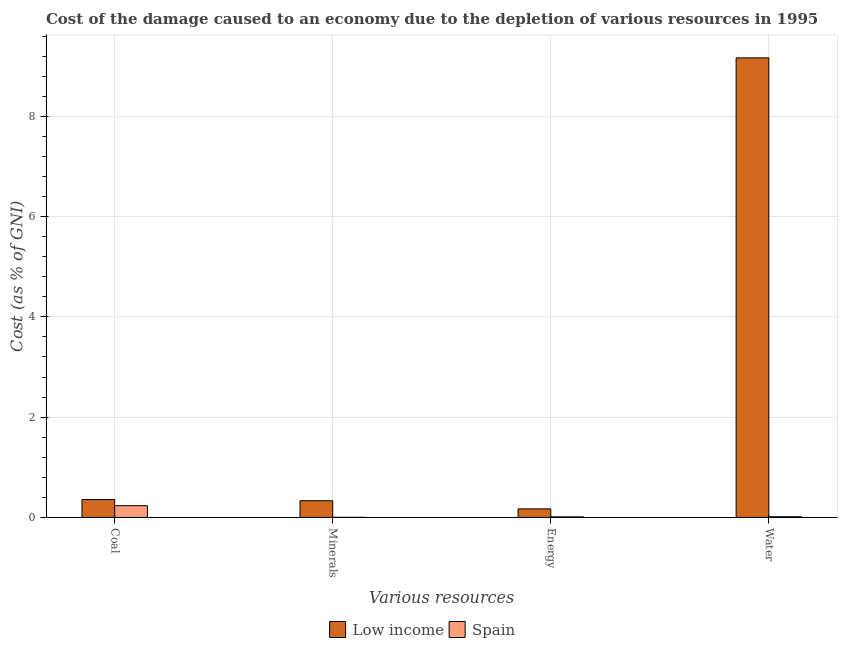How many different coloured bars are there?
Your response must be concise. 2. How many groups of bars are there?
Your answer should be very brief. 4. Are the number of bars per tick equal to the number of legend labels?
Your answer should be compact. Yes. Are the number of bars on each tick of the X-axis equal?
Provide a succinct answer. Yes. How many bars are there on the 1st tick from the left?
Your answer should be compact. 2. What is the label of the 2nd group of bars from the left?
Provide a short and direct response. Minerals. What is the cost of damage due to depletion of energy in Low income?
Provide a succinct answer. 0.17. Across all countries, what is the maximum cost of damage due to depletion of coal?
Provide a succinct answer. 0.36. Across all countries, what is the minimum cost of damage due to depletion of energy?
Your answer should be very brief. 0.01. In which country was the cost of damage due to depletion of energy maximum?
Provide a short and direct response. Low income. What is the total cost of damage due to depletion of energy in the graph?
Give a very brief answer. 0.18. What is the difference between the cost of damage due to depletion of coal in Spain and that in Low income?
Provide a short and direct response. -0.12. What is the difference between the cost of damage due to depletion of coal in Low income and the cost of damage due to depletion of energy in Spain?
Make the answer very short. 0.34. What is the average cost of damage due to depletion of minerals per country?
Ensure brevity in your answer.  0.17. What is the difference between the cost of damage due to depletion of energy and cost of damage due to depletion of minerals in Spain?
Your answer should be very brief. 0.01. What is the ratio of the cost of damage due to depletion of water in Spain to that in Low income?
Provide a succinct answer. 0. What is the difference between the highest and the second highest cost of damage due to depletion of energy?
Your answer should be very brief. 0.16. What is the difference between the highest and the lowest cost of damage due to depletion of water?
Make the answer very short. 9.15. What does the 1st bar from the left in Energy represents?
Your answer should be compact. Low income. How many bars are there?
Offer a very short reply. 8. Are all the bars in the graph horizontal?
Your response must be concise. No. How many countries are there in the graph?
Ensure brevity in your answer.  2. What is the title of the graph?
Offer a terse response. Cost of the damage caused to an economy due to the depletion of various resources in 1995 . Does "Brunei Darussalam" appear as one of the legend labels in the graph?
Provide a short and direct response. No. What is the label or title of the X-axis?
Offer a terse response. Various resources. What is the label or title of the Y-axis?
Give a very brief answer. Cost (as % of GNI). What is the Cost (as % of GNI) of Low income in Coal?
Your answer should be compact. 0.36. What is the Cost (as % of GNI) in Spain in Coal?
Provide a succinct answer. 0.23. What is the Cost (as % of GNI) in Low income in Minerals?
Offer a very short reply. 0.33. What is the Cost (as % of GNI) of Spain in Minerals?
Your answer should be very brief. 0. What is the Cost (as % of GNI) in Low income in Energy?
Make the answer very short. 0.17. What is the Cost (as % of GNI) in Spain in Energy?
Make the answer very short. 0.01. What is the Cost (as % of GNI) in Low income in Water?
Your response must be concise. 9.16. What is the Cost (as % of GNI) of Spain in Water?
Your response must be concise. 0.01. Across all Various resources, what is the maximum Cost (as % of GNI) of Low income?
Give a very brief answer. 9.16. Across all Various resources, what is the maximum Cost (as % of GNI) in Spain?
Make the answer very short. 0.23. Across all Various resources, what is the minimum Cost (as % of GNI) of Low income?
Offer a terse response. 0.17. Across all Various resources, what is the minimum Cost (as % of GNI) in Spain?
Provide a succinct answer. 0. What is the total Cost (as % of GNI) of Low income in the graph?
Offer a terse response. 10.02. What is the total Cost (as % of GNI) of Spain in the graph?
Offer a very short reply. 0.26. What is the difference between the Cost (as % of GNI) of Low income in Coal and that in Minerals?
Give a very brief answer. 0.02. What is the difference between the Cost (as % of GNI) in Spain in Coal and that in Minerals?
Provide a short and direct response. 0.23. What is the difference between the Cost (as % of GNI) of Low income in Coal and that in Energy?
Your response must be concise. 0.19. What is the difference between the Cost (as % of GNI) of Spain in Coal and that in Energy?
Offer a terse response. 0.22. What is the difference between the Cost (as % of GNI) of Low income in Coal and that in Water?
Your answer should be compact. -8.81. What is the difference between the Cost (as % of GNI) in Spain in Coal and that in Water?
Ensure brevity in your answer.  0.22. What is the difference between the Cost (as % of GNI) of Low income in Minerals and that in Energy?
Offer a terse response. 0.16. What is the difference between the Cost (as % of GNI) of Spain in Minerals and that in Energy?
Provide a short and direct response. -0.01. What is the difference between the Cost (as % of GNI) of Low income in Minerals and that in Water?
Make the answer very short. -8.83. What is the difference between the Cost (as % of GNI) of Spain in Minerals and that in Water?
Make the answer very short. -0.01. What is the difference between the Cost (as % of GNI) of Low income in Energy and that in Water?
Your response must be concise. -8.99. What is the difference between the Cost (as % of GNI) in Spain in Energy and that in Water?
Make the answer very short. -0. What is the difference between the Cost (as % of GNI) in Low income in Coal and the Cost (as % of GNI) in Spain in Minerals?
Ensure brevity in your answer.  0.35. What is the difference between the Cost (as % of GNI) of Low income in Coal and the Cost (as % of GNI) of Spain in Energy?
Your answer should be compact. 0.34. What is the difference between the Cost (as % of GNI) in Low income in Coal and the Cost (as % of GNI) in Spain in Water?
Keep it short and to the point. 0.34. What is the difference between the Cost (as % of GNI) in Low income in Minerals and the Cost (as % of GNI) in Spain in Energy?
Your response must be concise. 0.32. What is the difference between the Cost (as % of GNI) in Low income in Minerals and the Cost (as % of GNI) in Spain in Water?
Make the answer very short. 0.32. What is the difference between the Cost (as % of GNI) of Low income in Energy and the Cost (as % of GNI) of Spain in Water?
Provide a succinct answer. 0.16. What is the average Cost (as % of GNI) in Low income per Various resources?
Offer a terse response. 2.51. What is the average Cost (as % of GNI) of Spain per Various resources?
Offer a very short reply. 0.07. What is the difference between the Cost (as % of GNI) of Low income and Cost (as % of GNI) of Spain in Coal?
Keep it short and to the point. 0.12. What is the difference between the Cost (as % of GNI) of Low income and Cost (as % of GNI) of Spain in Minerals?
Provide a succinct answer. 0.33. What is the difference between the Cost (as % of GNI) in Low income and Cost (as % of GNI) in Spain in Energy?
Ensure brevity in your answer.  0.16. What is the difference between the Cost (as % of GNI) of Low income and Cost (as % of GNI) of Spain in Water?
Provide a succinct answer. 9.15. What is the ratio of the Cost (as % of GNI) in Low income in Coal to that in Minerals?
Keep it short and to the point. 1.07. What is the ratio of the Cost (as % of GNI) in Spain in Coal to that in Minerals?
Make the answer very short. 127.5. What is the ratio of the Cost (as % of GNI) in Low income in Coal to that in Energy?
Give a very brief answer. 2.09. What is the ratio of the Cost (as % of GNI) of Spain in Coal to that in Energy?
Offer a terse response. 20.49. What is the ratio of the Cost (as % of GNI) of Low income in Coal to that in Water?
Ensure brevity in your answer.  0.04. What is the ratio of the Cost (as % of GNI) in Spain in Coal to that in Water?
Provide a succinct answer. 17.66. What is the ratio of the Cost (as % of GNI) of Low income in Minerals to that in Energy?
Your response must be concise. 1.95. What is the ratio of the Cost (as % of GNI) of Spain in Minerals to that in Energy?
Offer a very short reply. 0.16. What is the ratio of the Cost (as % of GNI) of Low income in Minerals to that in Water?
Keep it short and to the point. 0.04. What is the ratio of the Cost (as % of GNI) of Spain in Minerals to that in Water?
Provide a short and direct response. 0.14. What is the ratio of the Cost (as % of GNI) in Low income in Energy to that in Water?
Make the answer very short. 0.02. What is the ratio of the Cost (as % of GNI) of Spain in Energy to that in Water?
Ensure brevity in your answer.  0.86. What is the difference between the highest and the second highest Cost (as % of GNI) of Low income?
Ensure brevity in your answer.  8.81. What is the difference between the highest and the second highest Cost (as % of GNI) of Spain?
Ensure brevity in your answer.  0.22. What is the difference between the highest and the lowest Cost (as % of GNI) in Low income?
Your answer should be very brief. 8.99. What is the difference between the highest and the lowest Cost (as % of GNI) of Spain?
Give a very brief answer. 0.23. 